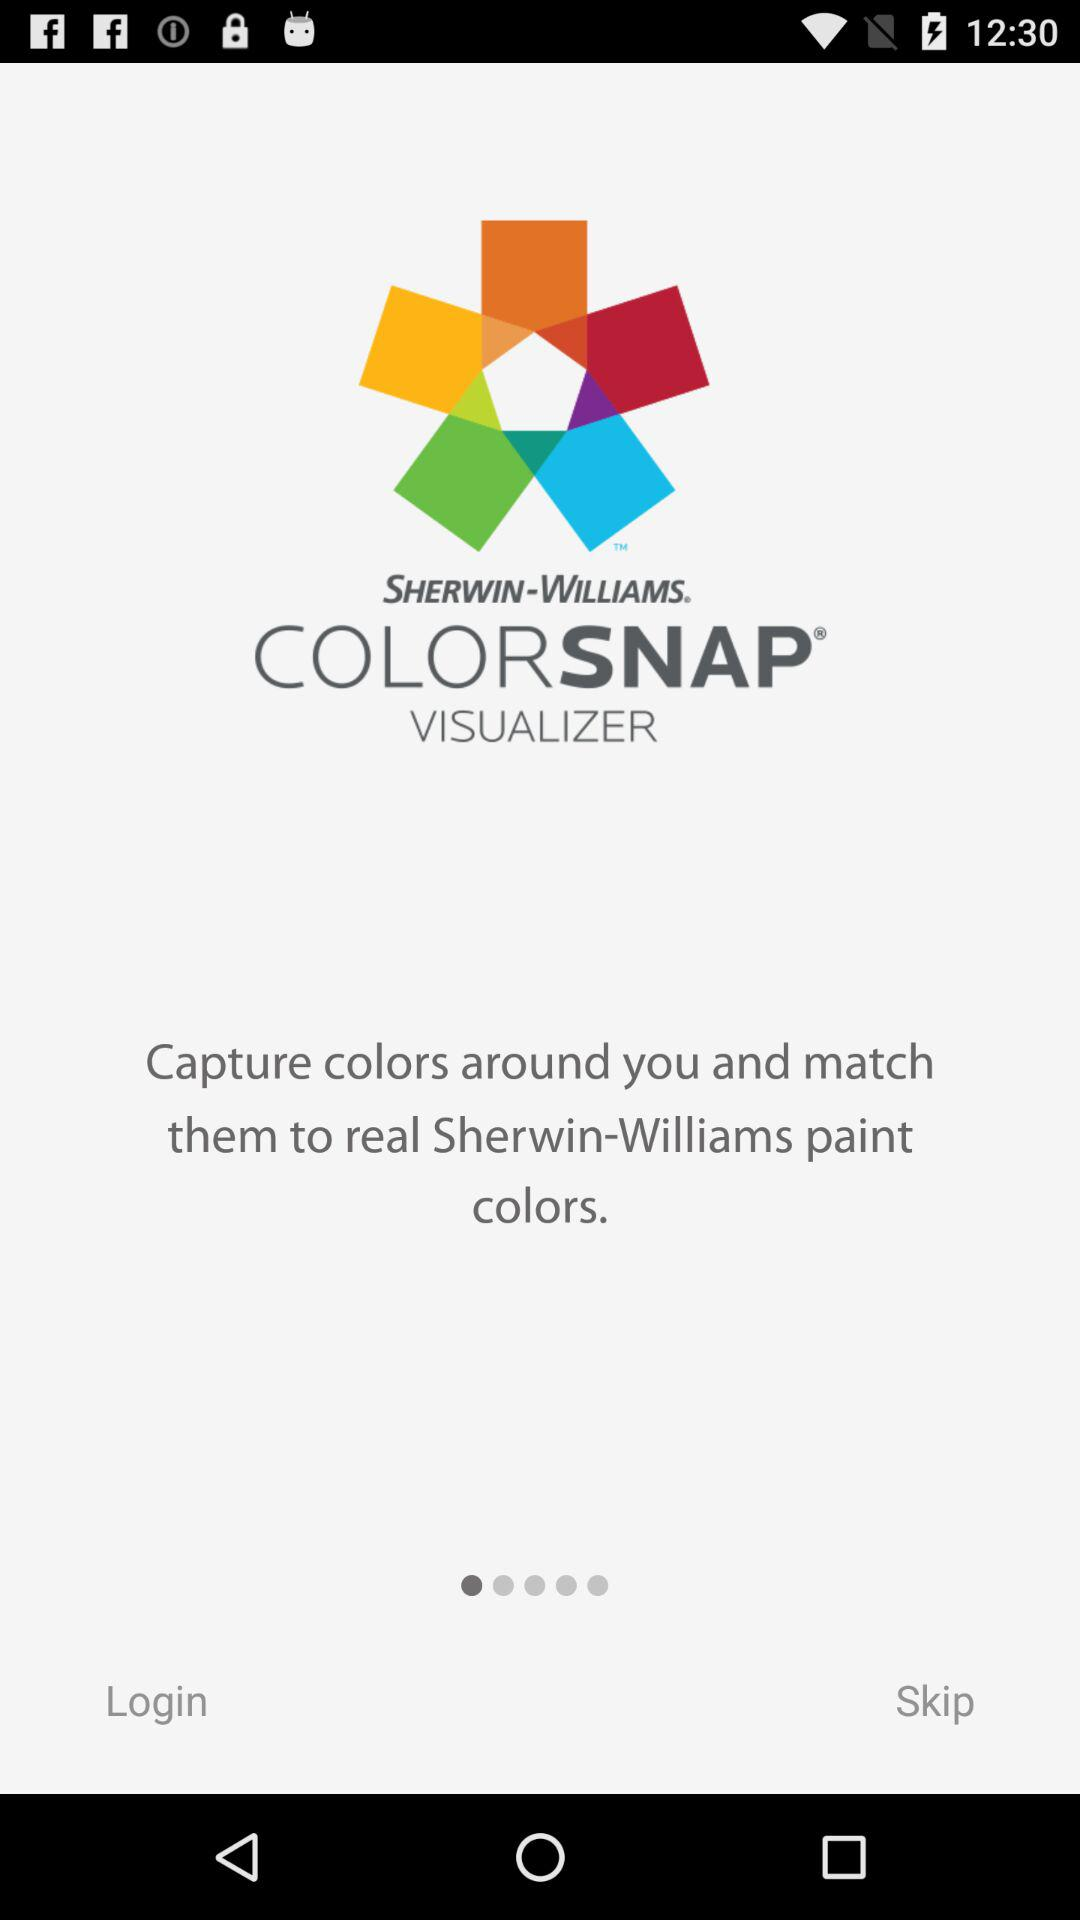What are the requirements to log in?
When the provided information is insufficient, respond with <no answer>. <no answer> 